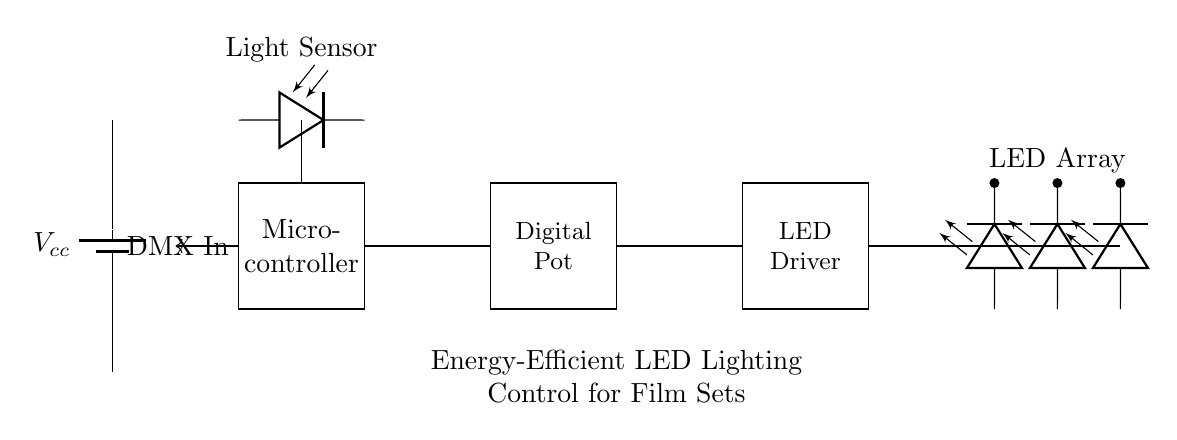What is the function of the microcontroller in this circuit? The microcontroller acts as the control unit that processes inputs (like the DMX signal) and regulates the outputs to other components, such as the digital potentiometer and LED driver.
Answer: Control unit What type of sensor is used to detect light? The circuit includes a photodiode labeled as the light sensor, which converts light into an electrical current.
Answer: Photodiode How many LEDs are there in the LED array? There are three LEDs represented in the LED array section of the circuit diagram.
Answer: Three What does DMX stand for in this circuit? DMX refers to Digital Multiplex, a protocol used for controlling lighting and effects in entertainment environments, allowing for control signals to be sent to the microcontroller.
Answer: Digital Multiplex How are the components connected to one another? The components are connected through lines representing electrical connections, with each component linked sequentially from the microcontroller to the digital potentiometer, then to the LED driver, and finally to the LED array.
Answer: Sequentially Why is a digital potentiometer used instead of an analog one? A digital potentiometer permits more precise control over resistance changes via digital commands from the microcontroller, improving energy efficiency in adjusting the brightness of the LEDs compared to an analog potentiometer.
Answer: Precise control What is the purpose of the battery in this circuit? The battery provides the necessary voltage and power supply for all the components connected in the circuit to function properly, ensuring they operate effectively during film set illumination.
Answer: Power supply 